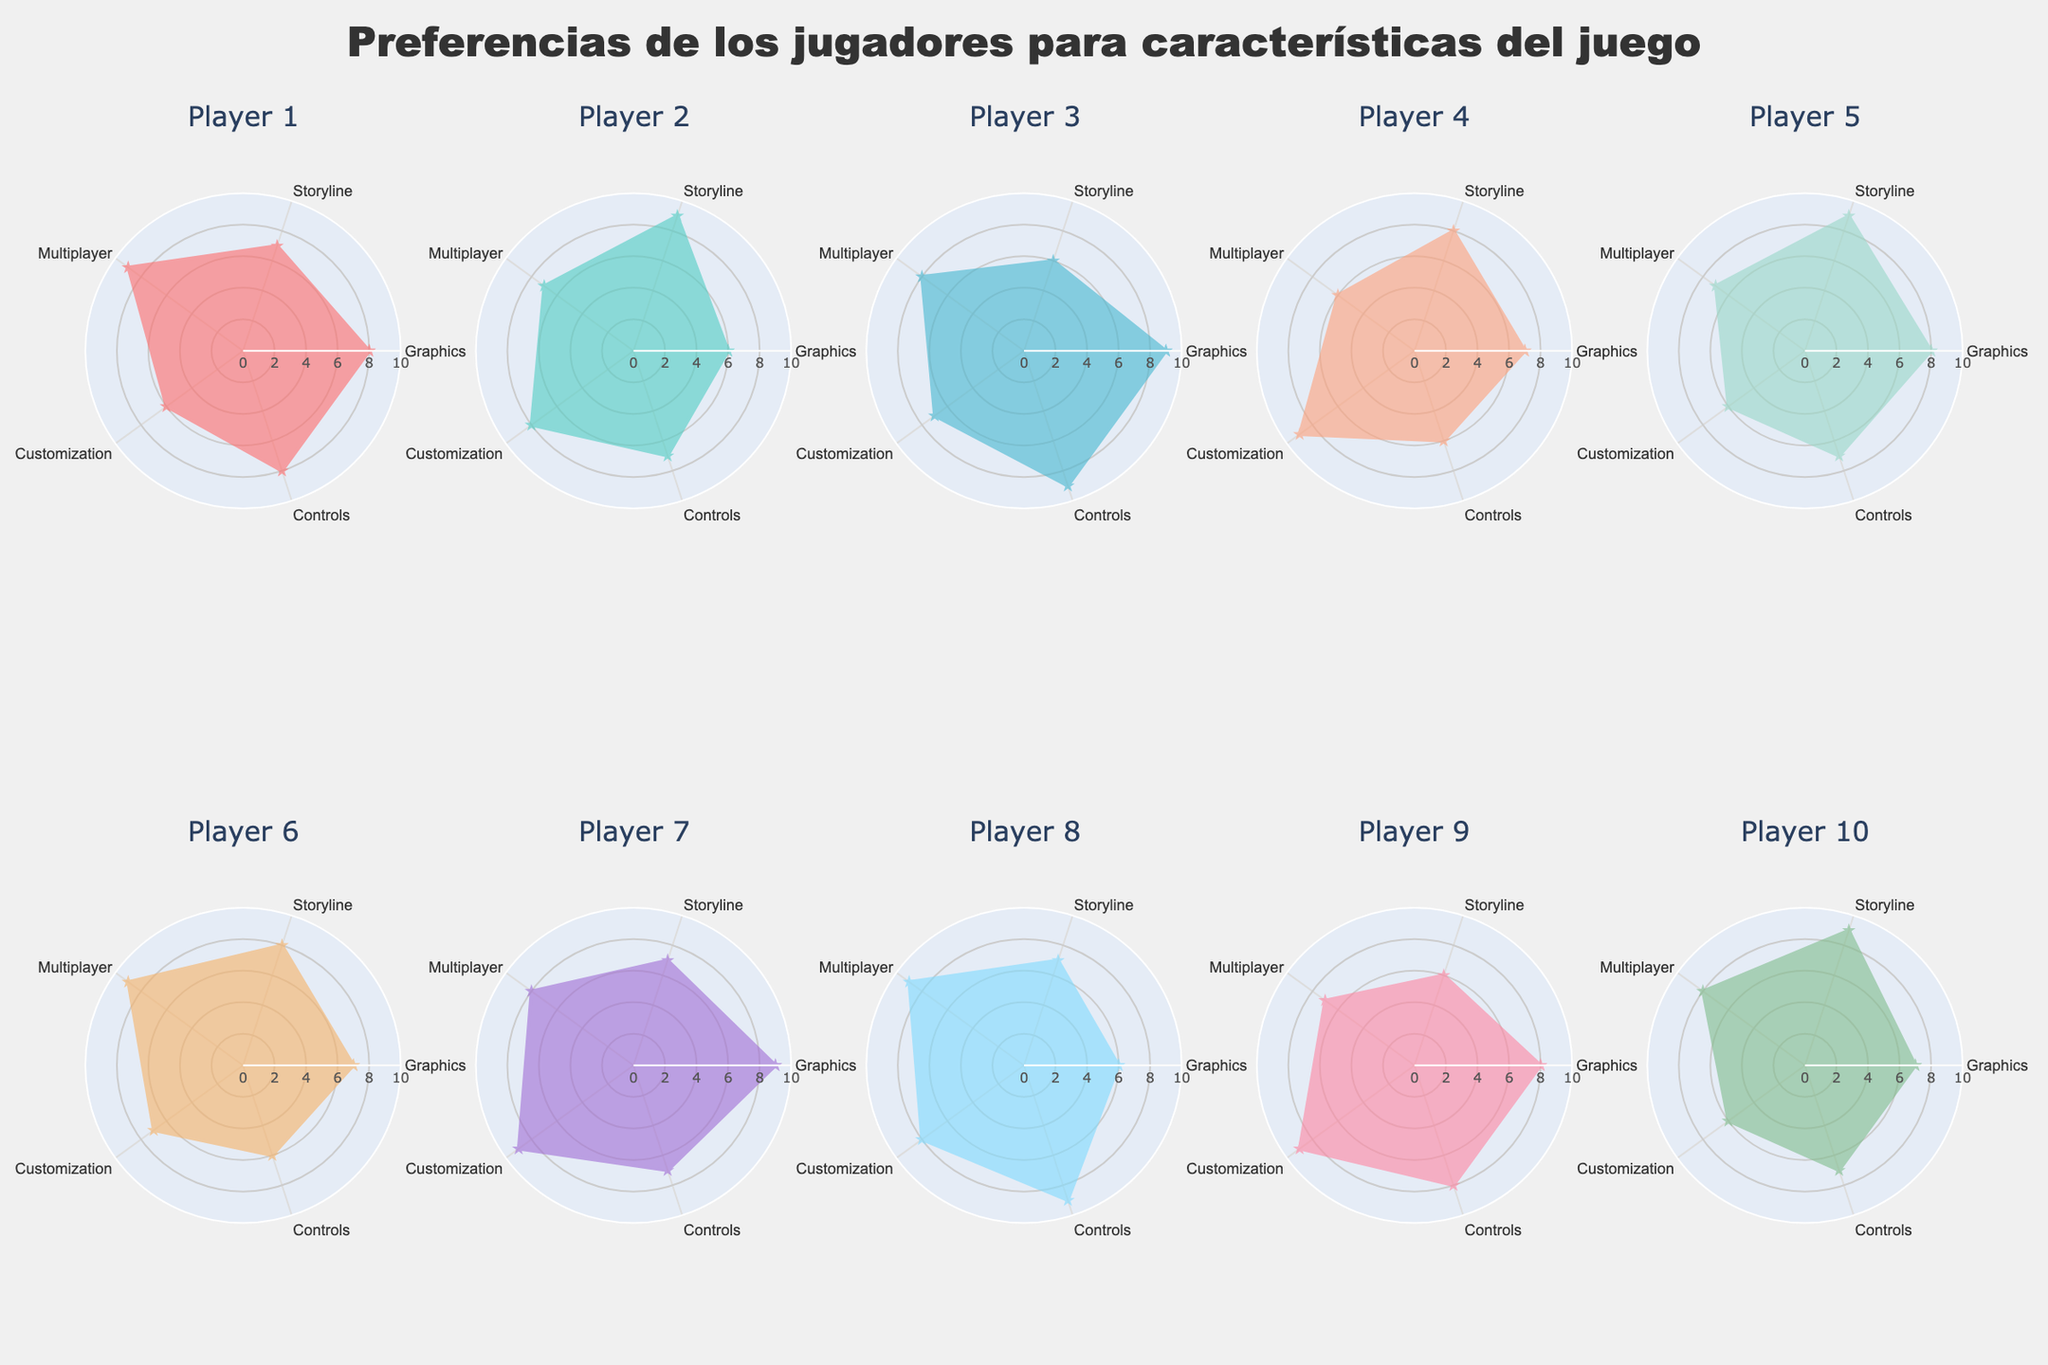¿Cuál es el título de la figura? El título de la figura está centrado en la parte superior y dice "Preferencias de los jugadores para características del juego". Es visible y permite entender rápidamente de qué trata la figura.
Answer: Preferencias de los jugadores para características del juego ¿Cuál jugador valora menos la característica de "Controles"? Observando cada radar, el valor más bajo en la característica de "Controles" es 6, y lo tienen los jugadores 4 y 6.
Answer: Jugador 4 y Jugador 6 ¿Qué jugador tiene la mayor valoración combinada de "Personalización" y "Multijugador"? Sumamos las valoraciones de "Personalización" y "Multijugador" para cada jugador. El Jugador 7 tiene una suma de 9 + 8 = 17, que es la mayor entre todos los jugadores.
Answer: Jugador 7 ¿Cuál es el color que representa al Jugador 3? Cada jugador tiene un color distinto en el radar, y el color del Jugador 3 es un azul claro que corresponde al tercer color en la paleta personalizada utilizada en la figura.
Answer: Azul claro ¿Cuál es el jugador que otorga la mayor valoración a la característica de "Historia"? Revisando todas las radiales para "Historia", encontramos que los jugadores 2, 5, y 10 le otorgan una valoración de 9, siendo esta la más alta.
Answer: Jugador 2, Jugador 5, y Jugador 10 ¿Cuál es la característica más valorada por el Jugador 9? Observando el radar del Jugador 9, la característica de "Personalización" tiene el valor más alto con una puntuación de 9.
Answer: Personalización ¿Qué jugadores tienen la misma valoración para "Gráficos"? Los jugadores con una valoración de 8 para "Gráficos" son Jugador 1, Jugador 5, y Jugador 9.
Answer: Jugador 1, Jugador 5, y Jugador 9 Entre los jugadores, ¿quién tiene la valoración promedio más alta en general? Calculamos el promedio de las valoraciones para cada jugador. Jugador 7 tiene un promedio de (9+7+8+9+7)/5 = 8, que es el más alto.
Answer: Jugador 7 